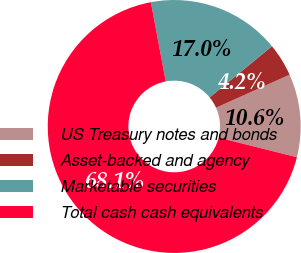<chart> <loc_0><loc_0><loc_500><loc_500><pie_chart><fcel>US Treasury notes and bonds<fcel>Asset-backed and agency<fcel>Marketable securities<fcel>Total cash cash equivalents<nl><fcel>10.62%<fcel>4.23%<fcel>17.01%<fcel>68.13%<nl></chart> 